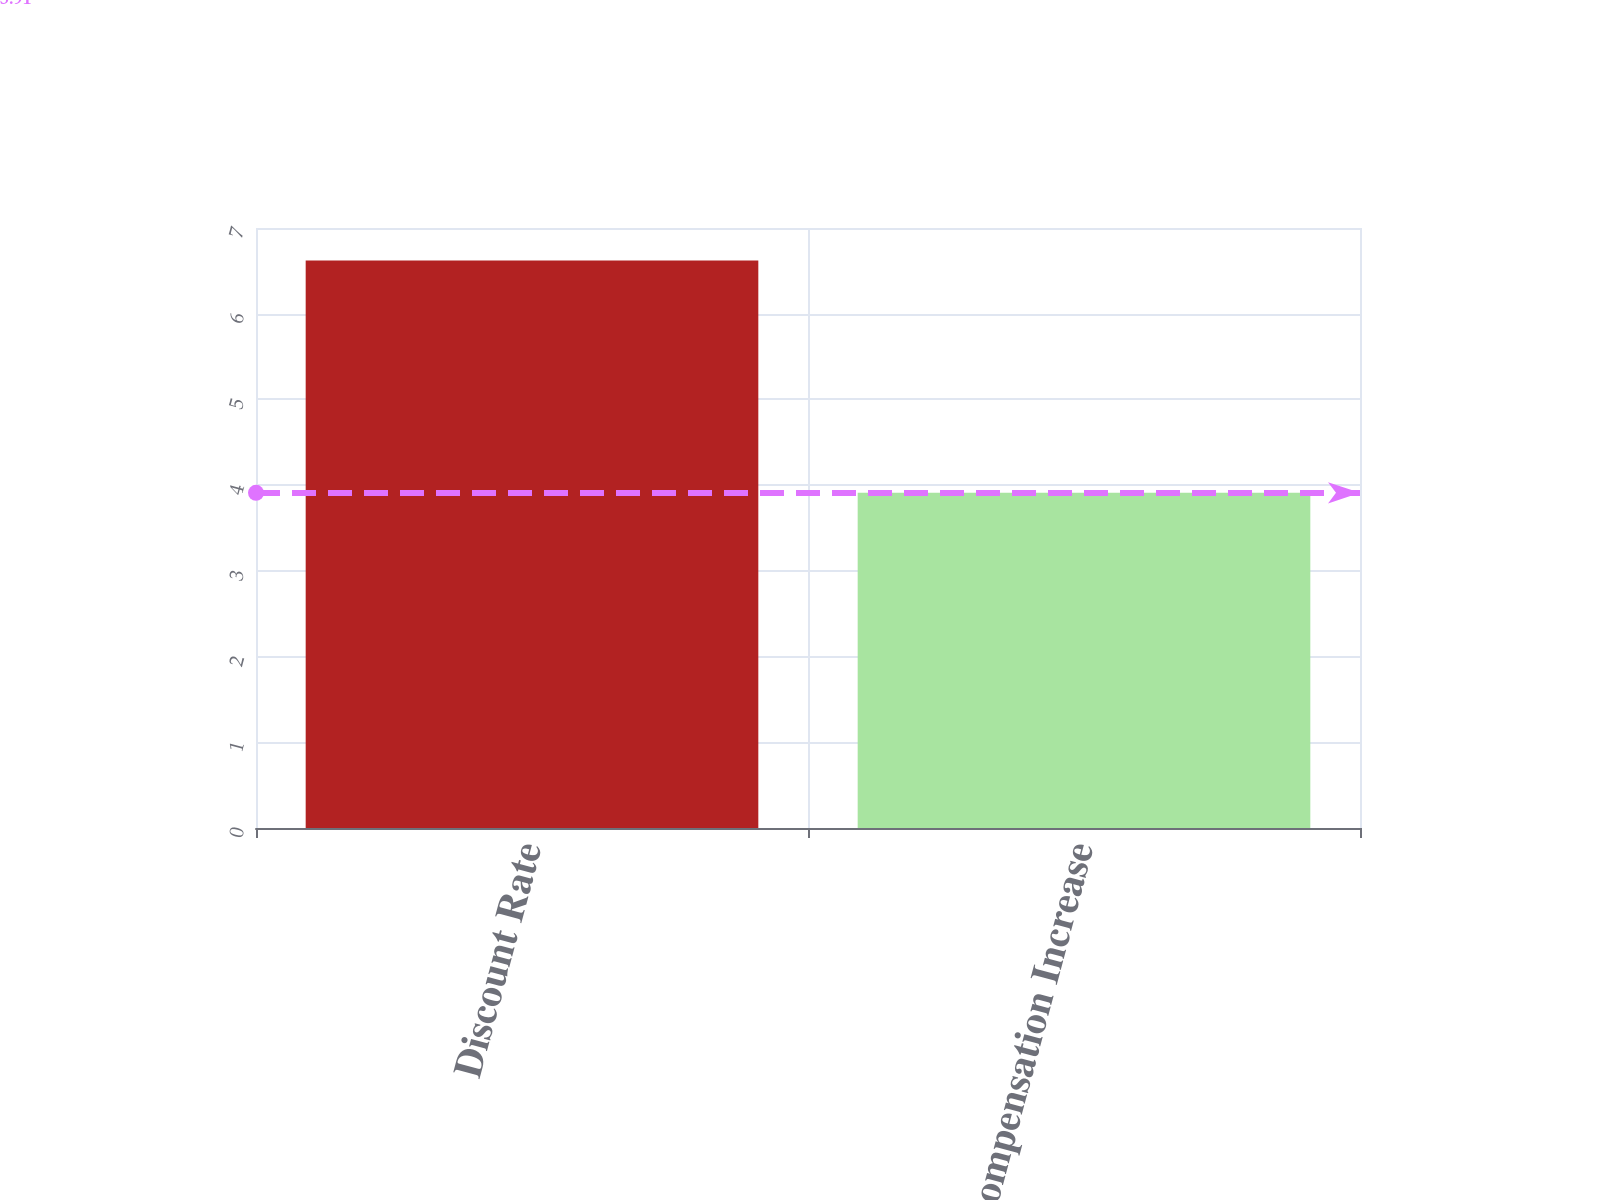Convert chart to OTSL. <chart><loc_0><loc_0><loc_500><loc_500><bar_chart><fcel>Discount Rate<fcel>Rate of Compensation Increase<nl><fcel>6.62<fcel>3.91<nl></chart> 